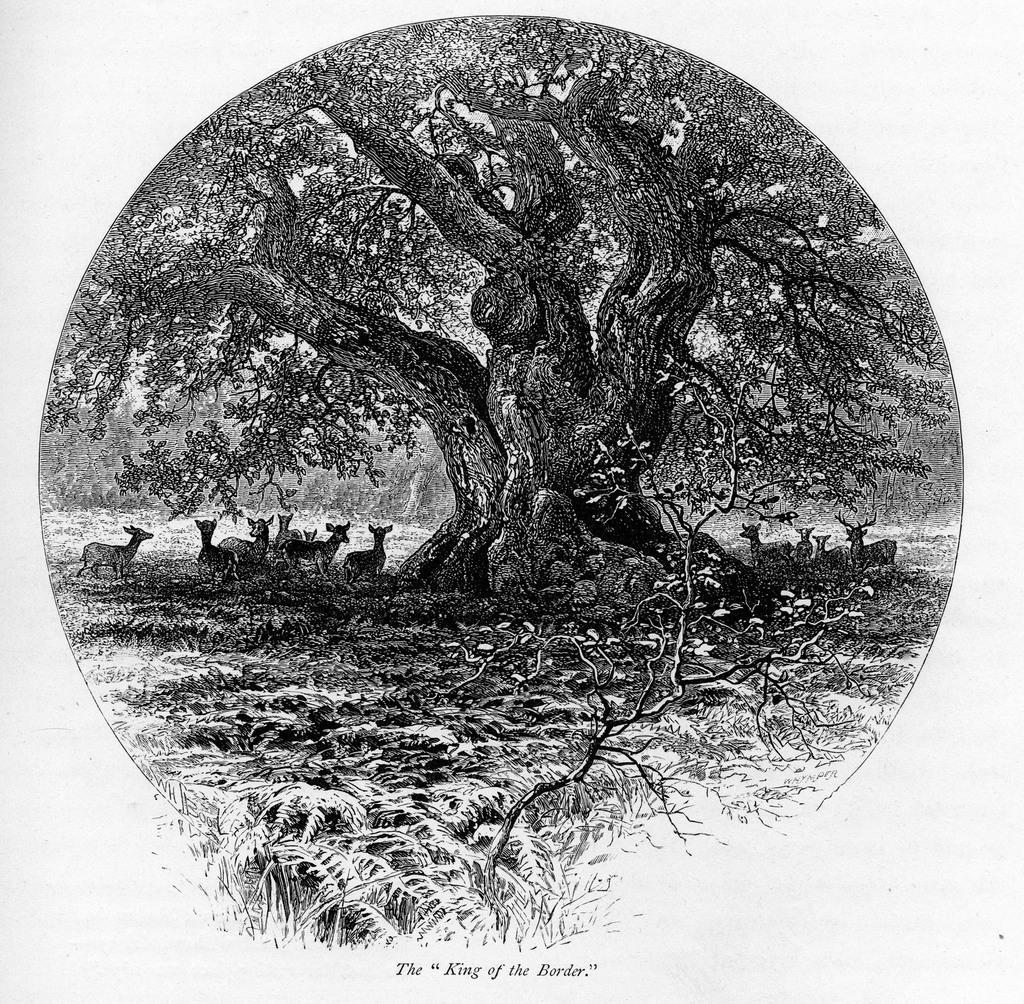In one or two sentences, can you explain what this image depicts? In this image we can see a black and picture. In the picture there are trees and a herd standing on the ground. 